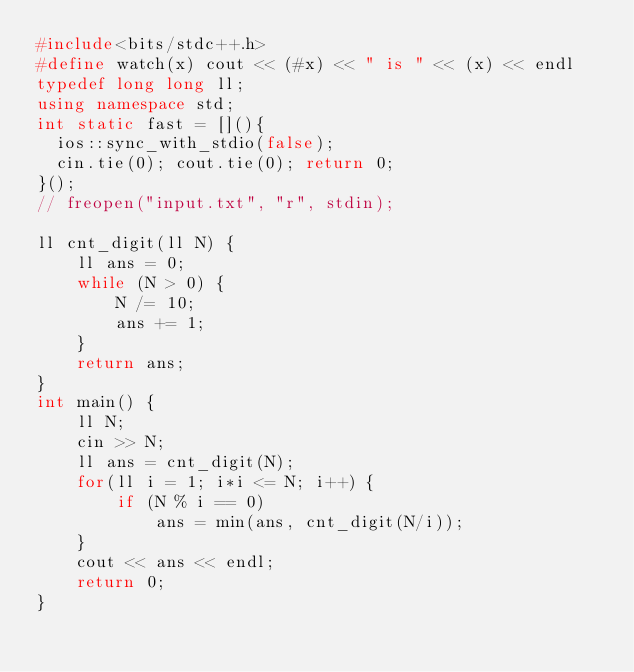Convert code to text. <code><loc_0><loc_0><loc_500><loc_500><_C++_>#include<bits/stdc++.h>
#define watch(x) cout << (#x) << " is " << (x) << endl
typedef long long ll;
using namespace std;
int static fast = [](){
  ios::sync_with_stdio(false);
  cin.tie(0); cout.tie(0); return 0;
}();
// freopen("input.txt", "r", stdin);

ll cnt_digit(ll N) {
    ll ans = 0;
    while (N > 0) {
        N /= 10;
        ans += 1;
    }
    return ans;
}
int main() {
    ll N;
    cin >> N;
    ll ans = cnt_digit(N);
    for(ll i = 1; i*i <= N; i++) {
        if (N % i == 0)
            ans = min(ans, cnt_digit(N/i));
    }
    cout << ans << endl;
    return 0;
}

</code> 